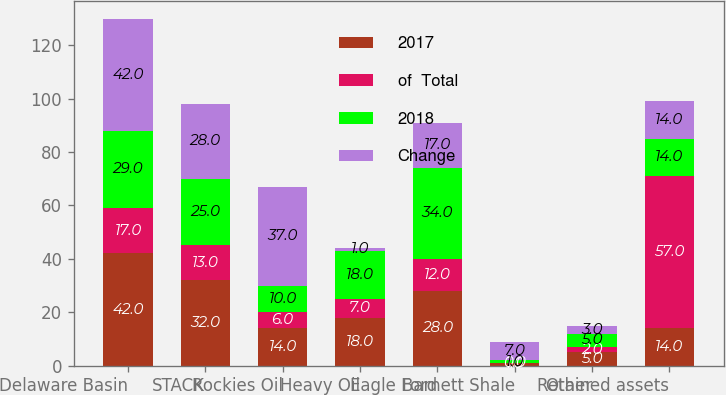Convert chart. <chart><loc_0><loc_0><loc_500><loc_500><stacked_bar_chart><ecel><fcel>Delaware Basin<fcel>STACK<fcel>Rockies Oil<fcel>Heavy Oil<fcel>Eagle Ford<fcel>Barnett Shale<fcel>Other<fcel>Retained assets<nl><fcel>2017<fcel>42<fcel>32<fcel>14<fcel>18<fcel>28<fcel>1<fcel>5<fcel>14<nl><fcel>of  Total<fcel>17<fcel>13<fcel>6<fcel>7<fcel>12<fcel>0<fcel>2<fcel>57<nl><fcel>2018<fcel>29<fcel>25<fcel>10<fcel>18<fcel>34<fcel>1<fcel>5<fcel>14<nl><fcel>Change<fcel>42<fcel>28<fcel>37<fcel>1<fcel>17<fcel>7<fcel>3<fcel>14<nl></chart> 